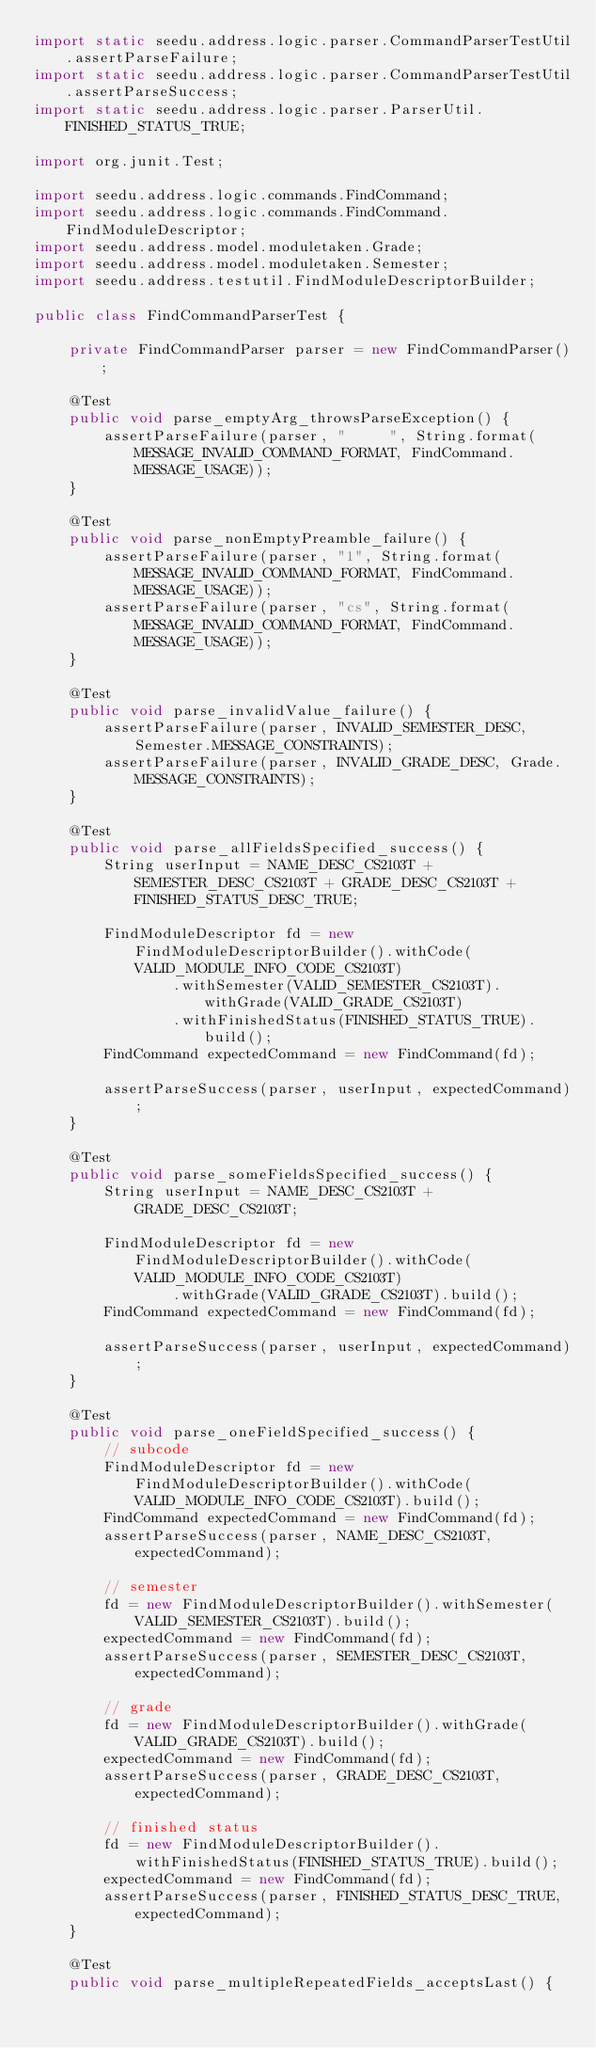<code> <loc_0><loc_0><loc_500><loc_500><_Java_>import static seedu.address.logic.parser.CommandParserTestUtil.assertParseFailure;
import static seedu.address.logic.parser.CommandParserTestUtil.assertParseSuccess;
import static seedu.address.logic.parser.ParserUtil.FINISHED_STATUS_TRUE;

import org.junit.Test;

import seedu.address.logic.commands.FindCommand;
import seedu.address.logic.commands.FindCommand.FindModuleDescriptor;
import seedu.address.model.moduletaken.Grade;
import seedu.address.model.moduletaken.Semester;
import seedu.address.testutil.FindModuleDescriptorBuilder;

public class FindCommandParserTest {

    private FindCommandParser parser = new FindCommandParser();

    @Test
    public void parse_emptyArg_throwsParseException() {
        assertParseFailure(parser, "     ", String.format(MESSAGE_INVALID_COMMAND_FORMAT, FindCommand.MESSAGE_USAGE));
    }

    @Test
    public void parse_nonEmptyPreamble_failure() {
        assertParseFailure(parser, "1", String.format(MESSAGE_INVALID_COMMAND_FORMAT, FindCommand.MESSAGE_USAGE));
        assertParseFailure(parser, "cs", String.format(MESSAGE_INVALID_COMMAND_FORMAT, FindCommand.MESSAGE_USAGE));
    }

    @Test
    public void parse_invalidValue_failure() {
        assertParseFailure(parser, INVALID_SEMESTER_DESC, Semester.MESSAGE_CONSTRAINTS);
        assertParseFailure(parser, INVALID_GRADE_DESC, Grade.MESSAGE_CONSTRAINTS);
    }

    @Test
    public void parse_allFieldsSpecified_success() {
        String userInput = NAME_DESC_CS2103T + SEMESTER_DESC_CS2103T + GRADE_DESC_CS2103T + FINISHED_STATUS_DESC_TRUE;

        FindModuleDescriptor fd = new FindModuleDescriptorBuilder().withCode(VALID_MODULE_INFO_CODE_CS2103T)
                .withSemester(VALID_SEMESTER_CS2103T).withGrade(VALID_GRADE_CS2103T)
                .withFinishedStatus(FINISHED_STATUS_TRUE).build();
        FindCommand expectedCommand = new FindCommand(fd);

        assertParseSuccess(parser, userInput, expectedCommand);
    }

    @Test
    public void parse_someFieldsSpecified_success() {
        String userInput = NAME_DESC_CS2103T + GRADE_DESC_CS2103T;

        FindModuleDescriptor fd = new FindModuleDescriptorBuilder().withCode(VALID_MODULE_INFO_CODE_CS2103T)
                .withGrade(VALID_GRADE_CS2103T).build();
        FindCommand expectedCommand = new FindCommand(fd);

        assertParseSuccess(parser, userInput, expectedCommand);
    }

    @Test
    public void parse_oneFieldSpecified_success() {
        // subcode
        FindModuleDescriptor fd = new FindModuleDescriptorBuilder().withCode(VALID_MODULE_INFO_CODE_CS2103T).build();
        FindCommand expectedCommand = new FindCommand(fd);
        assertParseSuccess(parser, NAME_DESC_CS2103T, expectedCommand);

        // semester
        fd = new FindModuleDescriptorBuilder().withSemester(VALID_SEMESTER_CS2103T).build();
        expectedCommand = new FindCommand(fd);
        assertParseSuccess(parser, SEMESTER_DESC_CS2103T, expectedCommand);

        // grade
        fd = new FindModuleDescriptorBuilder().withGrade(VALID_GRADE_CS2103T).build();
        expectedCommand = new FindCommand(fd);
        assertParseSuccess(parser, GRADE_DESC_CS2103T, expectedCommand);

        // finished status
        fd = new FindModuleDescriptorBuilder().withFinishedStatus(FINISHED_STATUS_TRUE).build();
        expectedCommand = new FindCommand(fd);
        assertParseSuccess(parser, FINISHED_STATUS_DESC_TRUE, expectedCommand);
    }

    @Test
    public void parse_multipleRepeatedFields_acceptsLast() {</code> 